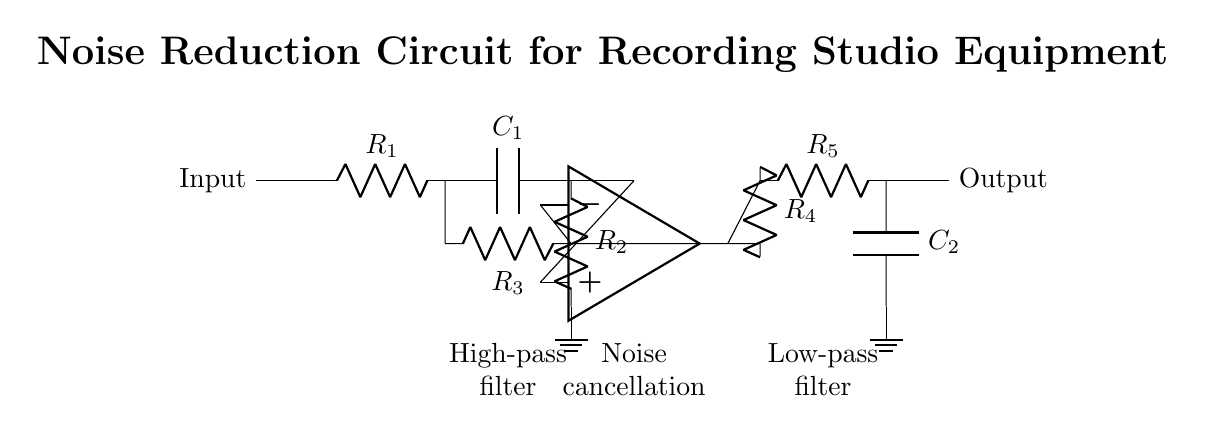What is the input component of the circuit? The input component is a resistor labeled R1, which is the first component directly connected to the input terminal.
Answer: Resistor What type of filter is used at the beginning of the circuit? The first filter in the circuit is a high-pass filter, indicated by the components immediately following R1, which include a capacitor (C1) and a resistor (R2).
Answer: High-pass filter How many resistors are present in the circuit? There are a total of five resistors in the circuit: R1, R2, R3, R4, and R5. They are clearly labeled on the diagram and contribute to various parts of the noise reduction functionality.
Answer: Five What is the role of the operational amplifier in this circuit? The operational amplifier (op amp) serves as the central element for noise cancellation, allowing the circuit to amplify and process signals while reducing noise. It is located in the middle section of the circuit, connected to R3 for feedback and input.
Answer: Noise cancellation What connection is made after R4 in the circuit? After R4, the connection leads to another resistor, R5, which is part of a low-pass filter, indicating the circuit’s focus on reducing high-frequency noise and allowing low-frequency signals to pass through.
Answer: R5 (low-pass filter) What component connects the output to ground? The component connecting the output of the low-pass filter to ground is a capacitor, labeled C2, which completes the filter setup for the circuit. It is positioned at the end of the output line following R5.
Answer: Capacitor 